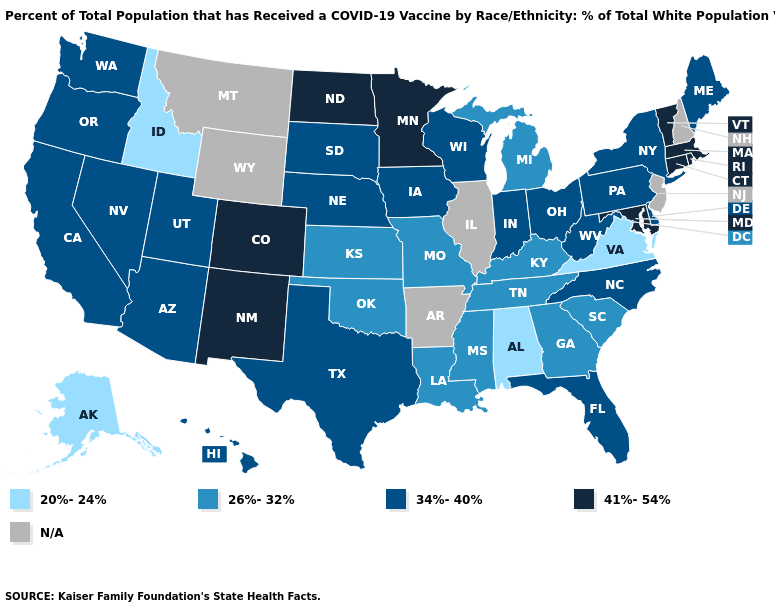What is the lowest value in the Northeast?
Write a very short answer. 34%-40%. Name the states that have a value in the range 26%-32%?
Quick response, please. Georgia, Kansas, Kentucky, Louisiana, Michigan, Mississippi, Missouri, Oklahoma, South Carolina, Tennessee. What is the value of New York?
Concise answer only. 34%-40%. What is the highest value in the USA?
Keep it brief. 41%-54%. Among the states that border Vermont , which have the highest value?
Answer briefly. Massachusetts. What is the highest value in the Northeast ?
Quick response, please. 41%-54%. Is the legend a continuous bar?
Concise answer only. No. Name the states that have a value in the range 20%-24%?
Be succinct. Alabama, Alaska, Idaho, Virginia. What is the highest value in the West ?
Give a very brief answer. 41%-54%. Does the map have missing data?
Write a very short answer. Yes. How many symbols are there in the legend?
Keep it brief. 5. Does Virginia have the lowest value in the USA?
Short answer required. Yes. What is the highest value in the South ?
Keep it brief. 41%-54%. Does the map have missing data?
Answer briefly. Yes. What is the value of Hawaii?
Write a very short answer. 34%-40%. 